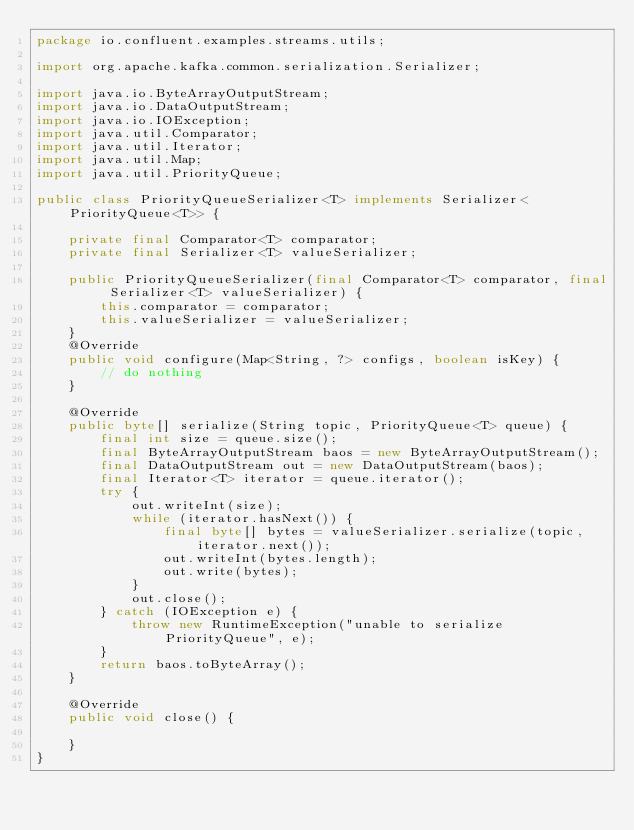<code> <loc_0><loc_0><loc_500><loc_500><_Java_>package io.confluent.examples.streams.utils;

import org.apache.kafka.common.serialization.Serializer;

import java.io.ByteArrayOutputStream;
import java.io.DataOutputStream;
import java.io.IOException;
import java.util.Comparator;
import java.util.Iterator;
import java.util.Map;
import java.util.PriorityQueue;

public class PriorityQueueSerializer<T> implements Serializer<PriorityQueue<T>> {

    private final Comparator<T> comparator;
    private final Serializer<T> valueSerializer;

    public PriorityQueueSerializer(final Comparator<T> comparator, final Serializer<T> valueSerializer) {
        this.comparator = comparator;
        this.valueSerializer = valueSerializer;
    }
    @Override
    public void configure(Map<String, ?> configs, boolean isKey) {
        // do nothing
    }

    @Override
    public byte[] serialize(String topic, PriorityQueue<T> queue) {
        final int size = queue.size();
        final ByteArrayOutputStream baos = new ByteArrayOutputStream();
        final DataOutputStream out = new DataOutputStream(baos);
        final Iterator<T> iterator = queue.iterator();
        try {
            out.writeInt(size);
            while (iterator.hasNext()) {
                final byte[] bytes = valueSerializer.serialize(topic, iterator.next());
                out.writeInt(bytes.length);
                out.write(bytes);
            }
            out.close();
        } catch (IOException e) {
            throw new RuntimeException("unable to serialize PriorityQueue", e);
        }
        return baos.toByteArray();
    }

    @Override
    public void close() {

    }
}
</code> 